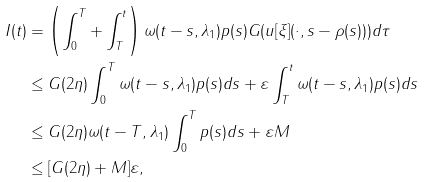<formula> <loc_0><loc_0><loc_500><loc_500>I ( t ) & = \left ( \int _ { 0 } ^ { T } + \int _ { T } ^ { t } \right ) \omega ( t - s , \lambda _ { 1 } ) p ( s ) G ( \| u [ \xi ] ( \cdot , s - \rho ( s ) ) \| ) d \tau \\ & \leq G ( 2 \eta ) \int _ { 0 } ^ { T } \omega ( t - s , \lambda _ { 1 } ) p ( s ) d s + \varepsilon \int _ { T } ^ { t } \omega ( t - s , \lambda _ { 1 } ) p ( s ) d s \\ & \leq G ( 2 \eta ) \omega ( t - T , \lambda _ { 1 } ) \int _ { 0 } ^ { T } p ( s ) d s + \varepsilon M \\ & \leq [ G ( 2 \eta ) + M ] \varepsilon ,</formula> 